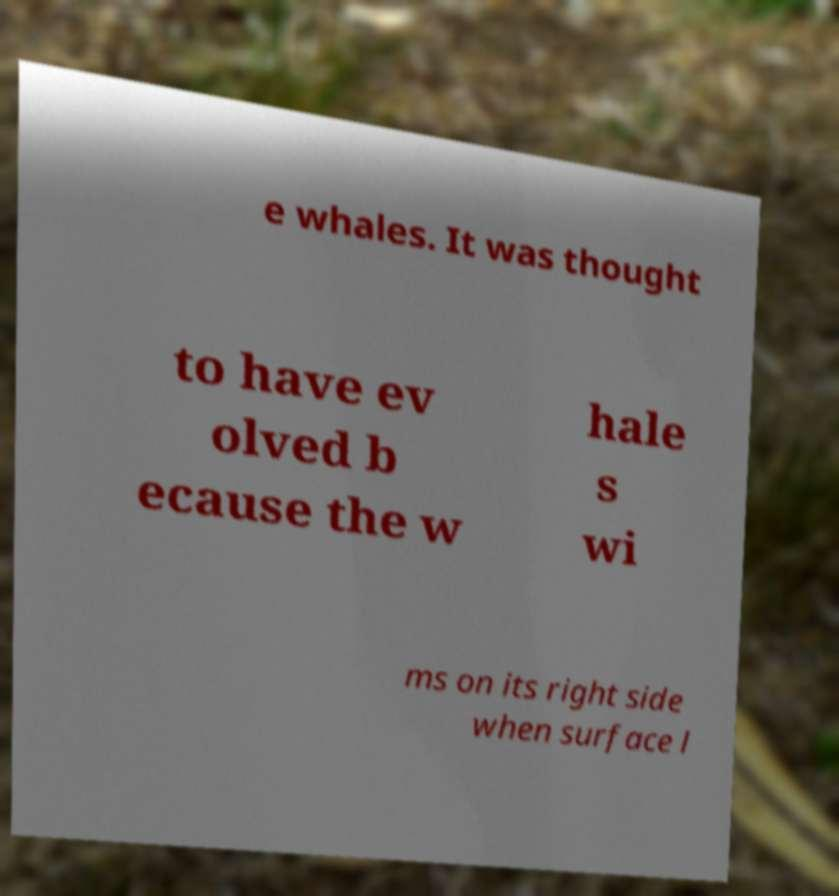Please identify and transcribe the text found in this image. e whales. It was thought to have ev olved b ecause the w hale s wi ms on its right side when surface l 